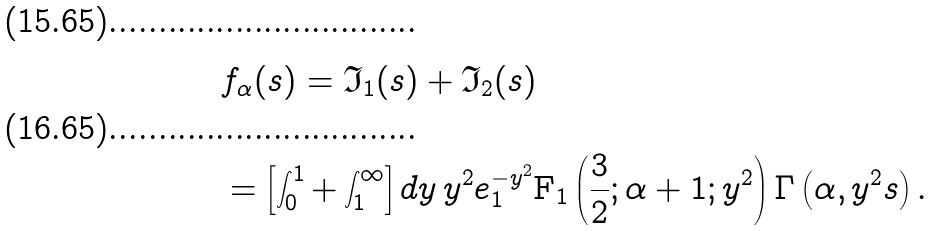<formula> <loc_0><loc_0><loc_500><loc_500>& f _ { \alpha } ( s ) = \mathfrak { I } _ { 1 } ( s ) + \mathfrak { I } _ { 2 } ( s ) \\ & = \left [ \int _ { 0 } ^ { 1 } + \int _ { 1 } ^ { \infty } \right ] d y \, y ^ { 2 } e ^ { - y ^ { 2 } } _ { 1 } \text {F} _ { 1 } \left ( \frac { 3 } { 2 } ; \alpha + 1 ; y ^ { 2 } \right ) \Gamma \left ( \alpha , y ^ { 2 } s \right ) .</formula> 